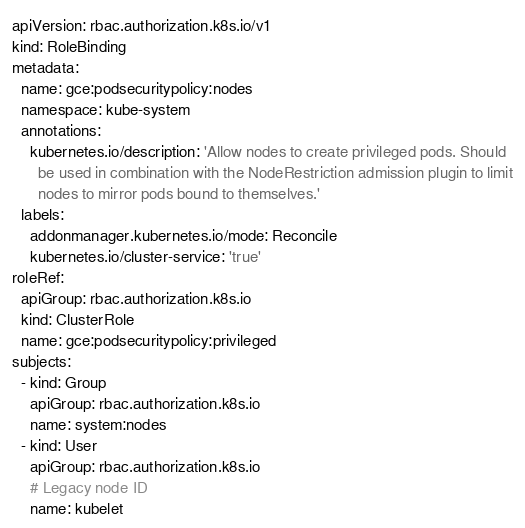Convert code to text. <code><loc_0><loc_0><loc_500><loc_500><_YAML_>apiVersion: rbac.authorization.k8s.io/v1
kind: RoleBinding
metadata:
  name: gce:podsecuritypolicy:nodes
  namespace: kube-system
  annotations:
    kubernetes.io/description: 'Allow nodes to create privileged pods. Should
      be used in combination with the NodeRestriction admission plugin to limit
      nodes to mirror pods bound to themselves.'
  labels:
    addonmanager.kubernetes.io/mode: Reconcile
    kubernetes.io/cluster-service: 'true'
roleRef:
  apiGroup: rbac.authorization.k8s.io
  kind: ClusterRole
  name: gce:podsecuritypolicy:privileged
subjects:
  - kind: Group
    apiGroup: rbac.authorization.k8s.io
    name: system:nodes
  - kind: User
    apiGroup: rbac.authorization.k8s.io
    # Legacy node ID
    name: kubelet
</code> 